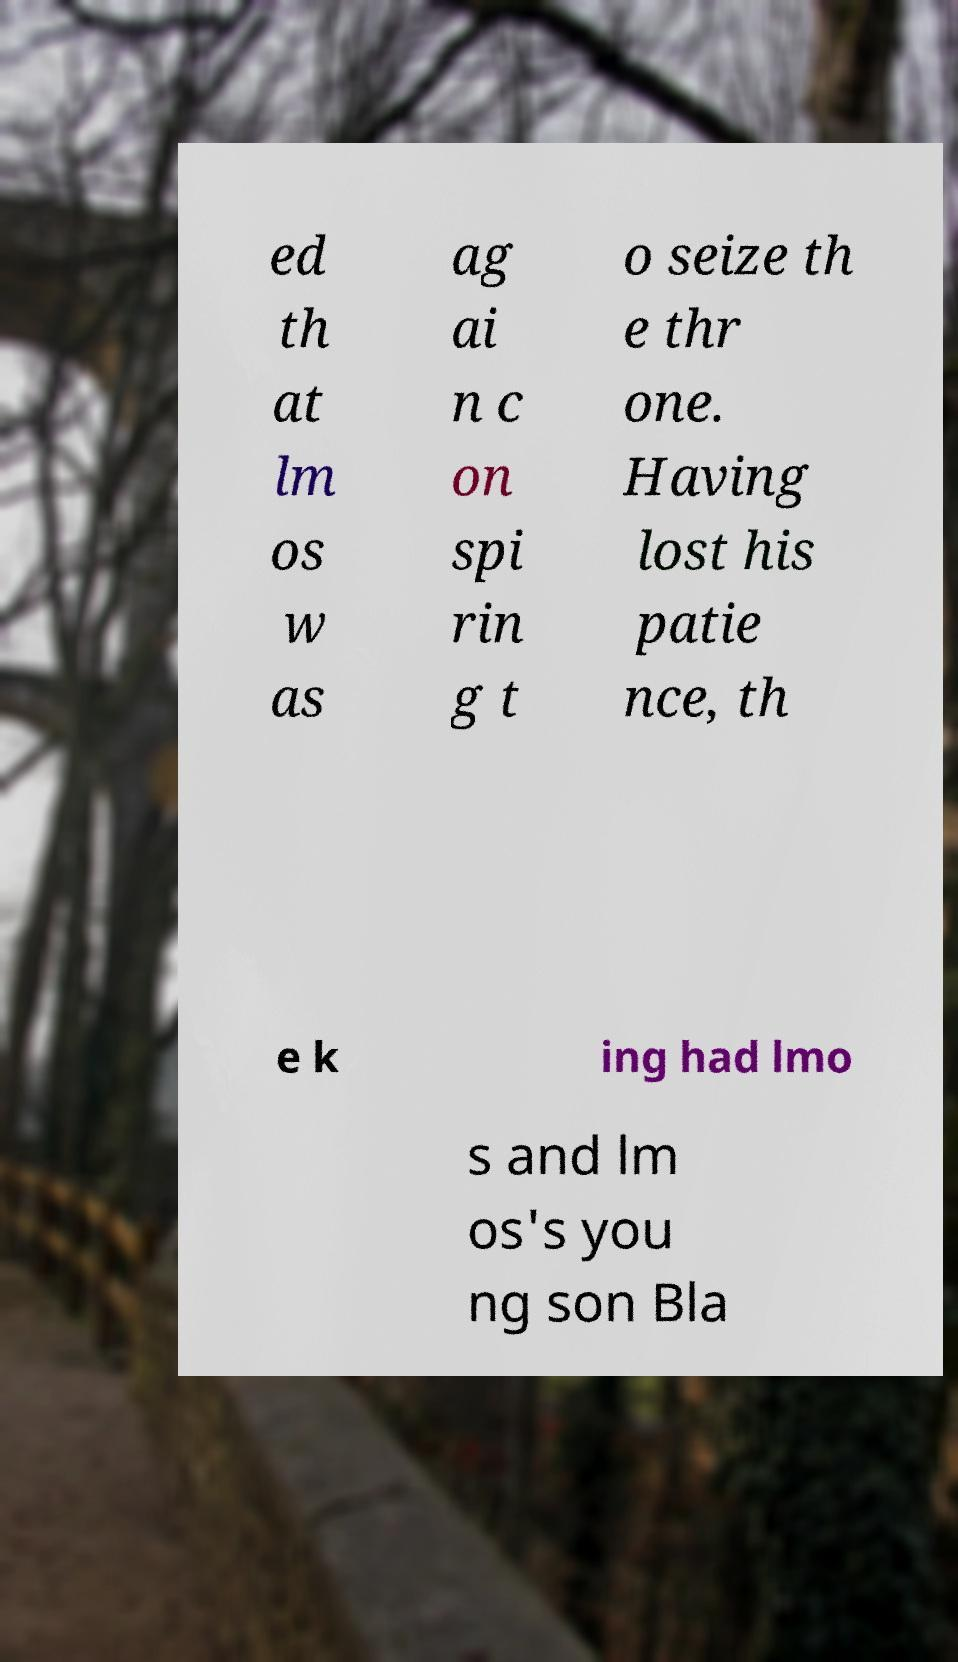Please identify and transcribe the text found in this image. ed th at lm os w as ag ai n c on spi rin g t o seize th e thr one. Having lost his patie nce, th e k ing had lmo s and lm os's you ng son Bla 